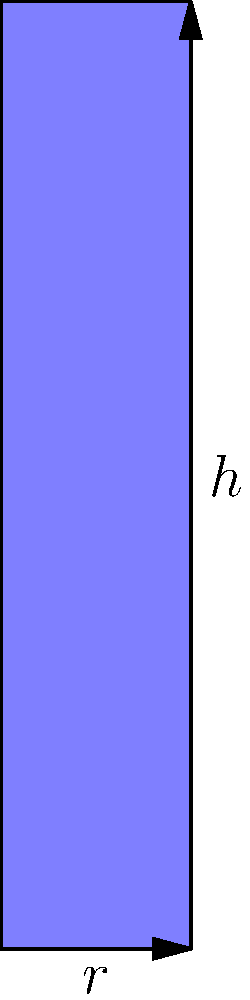As a tequila enthusiast, you're curious about the volume of a unique cylindrical tequila bottle. The bottle has a height of 20 cm and a radius of 4 cm. What is the volume of this tequila bottle in milliliters (mL)? (Use $\pi \approx 3.14$ for your calculation) To find the volume of the cylindrical tequila bottle, we'll follow these steps:

1. Recall the formula for the volume of a cylinder:
   $$V = \pi r^2 h$$
   where $V$ is volume, $r$ is radius, and $h$ is height.

2. Insert the given values:
   $r = 4$ cm
   $h = 20$ cm
   $\pi \approx 3.14$

3. Calculate the volume:
   $$V = 3.14 \times (4\text{ cm})^2 \times 20\text{ cm}$$
   $$V = 3.14 \times 16\text{ cm}^2 \times 20\text{ cm}$$
   $$V = 1005.76\text{ cm}^3$$

4. Convert cubic centimeters to milliliters:
   1 cm³ = 1 mL, so the volume in mL is the same as in cm³.

Therefore, the volume of the tequila bottle is approximately 1005.76 mL.
Answer: 1005.76 mL 